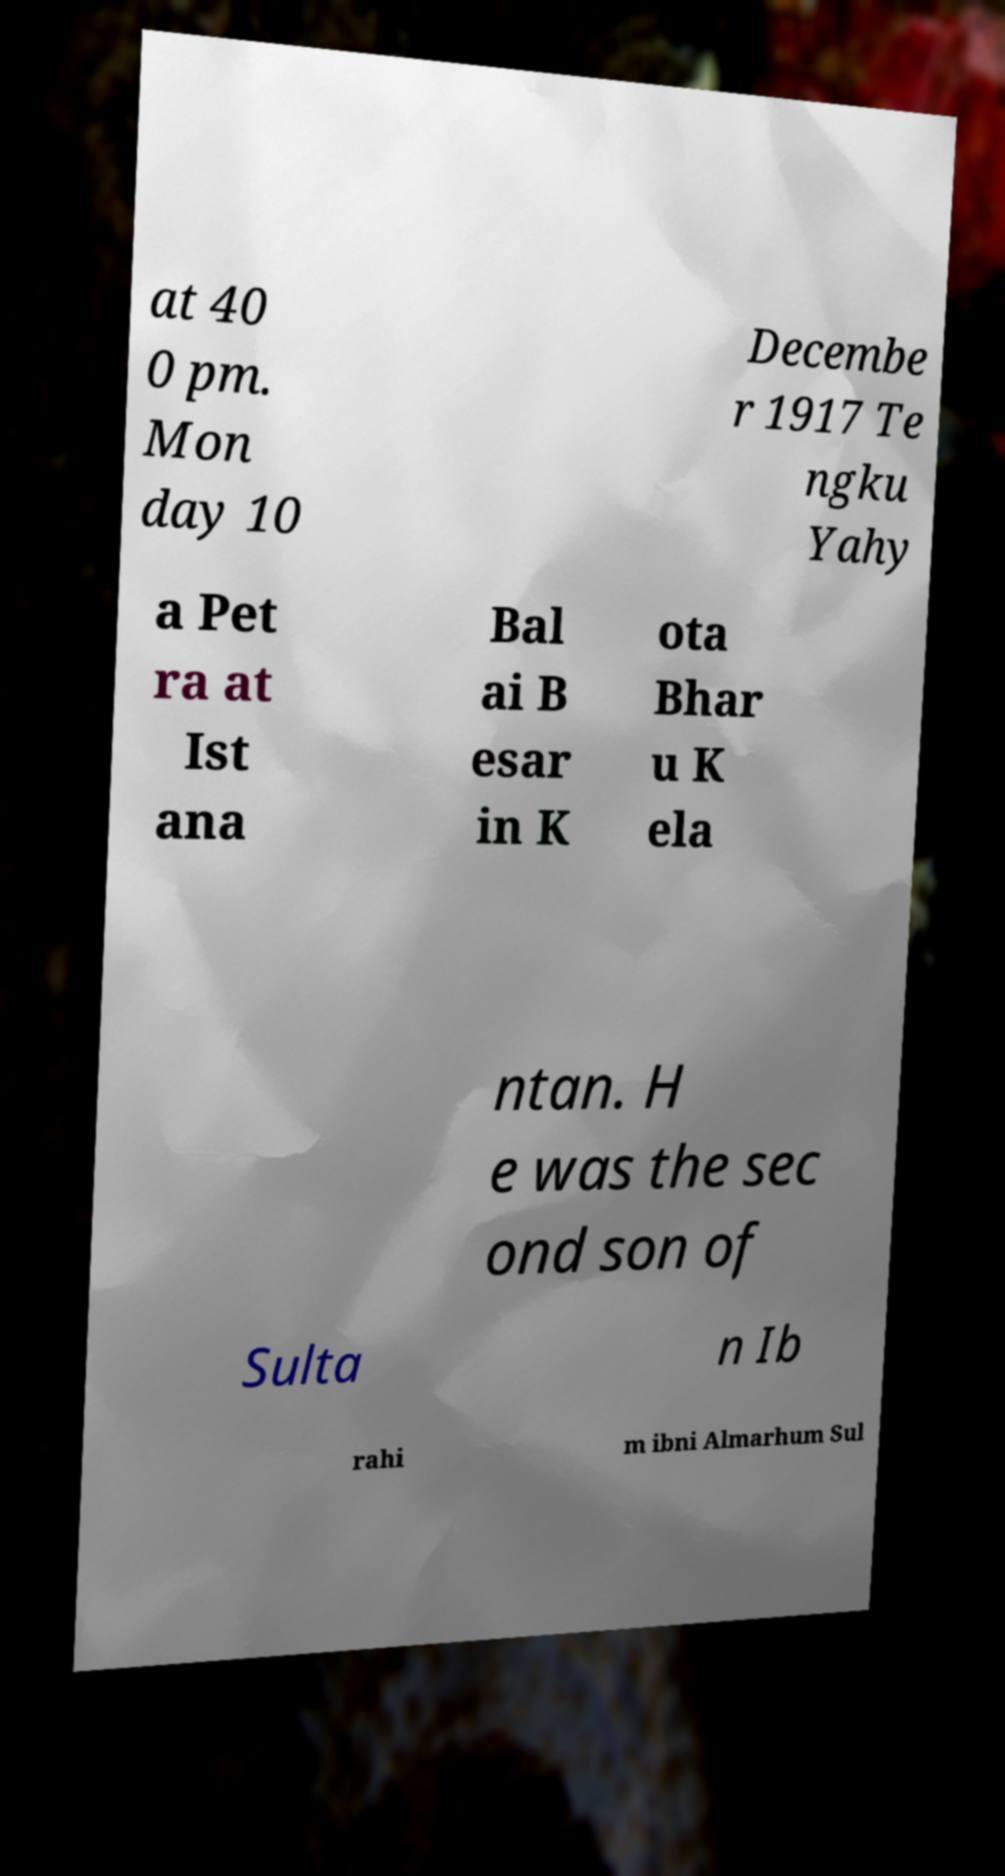For documentation purposes, I need the text within this image transcribed. Could you provide that? at 40 0 pm. Mon day 10 Decembe r 1917 Te ngku Yahy a Pet ra at Ist ana Bal ai B esar in K ota Bhar u K ela ntan. H e was the sec ond son of Sulta n Ib rahi m ibni Almarhum Sul 